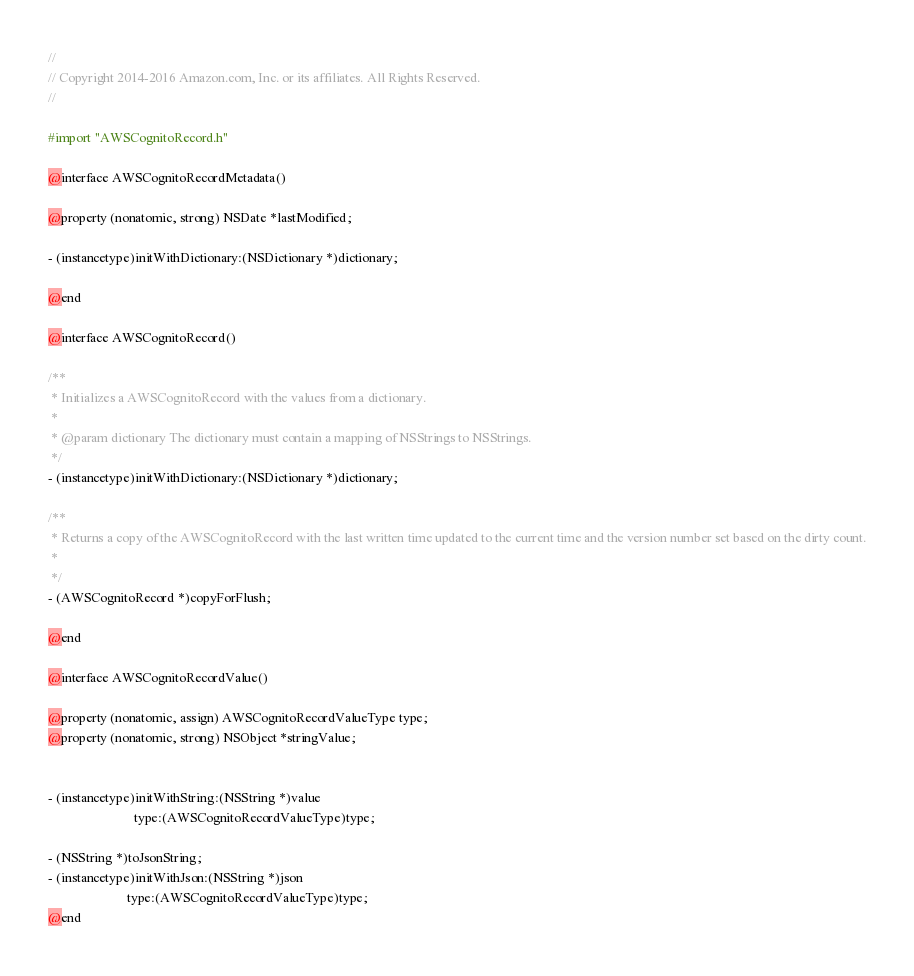Convert code to text. <code><loc_0><loc_0><loc_500><loc_500><_C_>//
// Copyright 2014-2016 Amazon.com, Inc. or its affiliates. All Rights Reserved.
//

#import "AWSCognitoRecord.h"

@interface AWSCognitoRecordMetadata()

@property (nonatomic, strong) NSDate *lastModified;

- (instancetype)initWithDictionary:(NSDictionary *)dictionary;

@end

@interface AWSCognitoRecord()

/**
 * Initializes a AWSCognitoRecord with the values from a dictionary.
 *
 * @param dictionary The dictionary must contain a mapping of NSStrings to NSStrings.
 */
- (instancetype)initWithDictionary:(NSDictionary *)dictionary;

/**
 * Returns a copy of the AWSCognitoRecord with the last written time updated to the current time and the version number set based on the dirty count.
 *
 */
- (AWSCognitoRecord *)copyForFlush;

@end

@interface AWSCognitoRecordValue()

@property (nonatomic, assign) AWSCognitoRecordValueType type;
@property (nonatomic, strong) NSObject *stringValue;


- (instancetype)initWithString:(NSString *)value
                          type:(AWSCognitoRecordValueType)type;

- (NSString *)toJsonString;
- (instancetype)initWithJson:(NSString *)json
                        type:(AWSCognitoRecordValueType)type;
@end</code> 